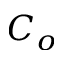<formula> <loc_0><loc_0><loc_500><loc_500>C _ { o }</formula> 